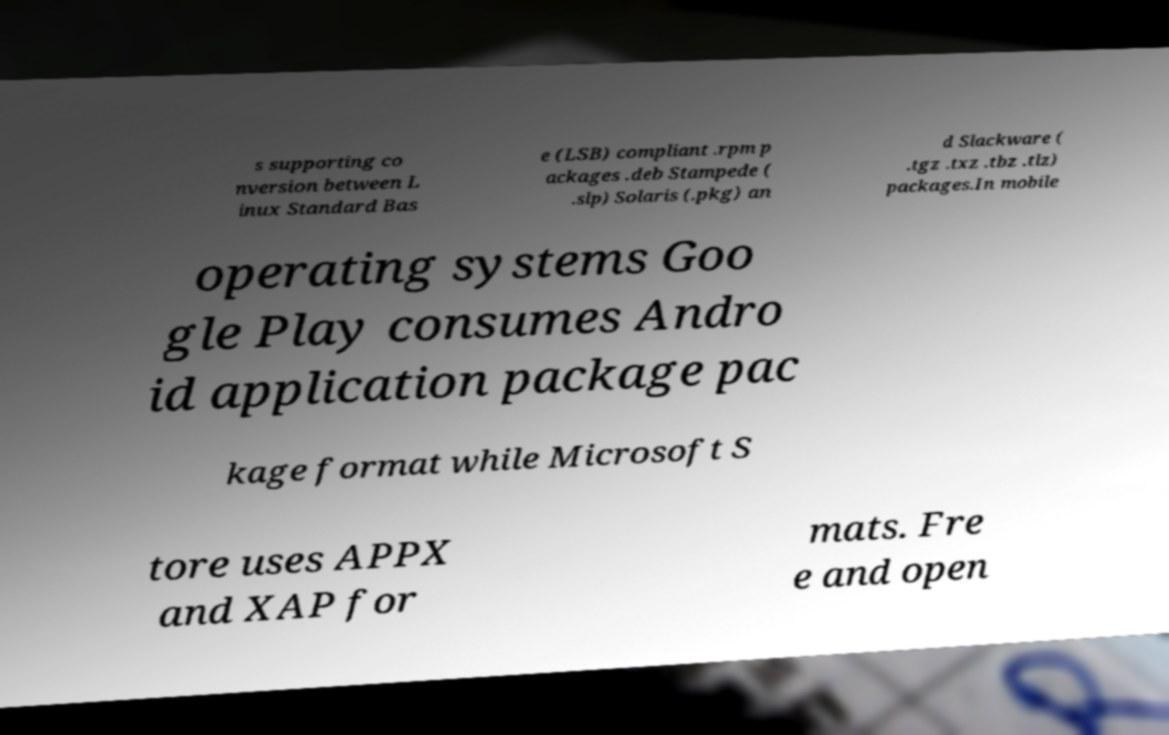Please read and relay the text visible in this image. What does it say? s supporting co nversion between L inux Standard Bas e (LSB) compliant .rpm p ackages .deb Stampede ( .slp) Solaris (.pkg) an d Slackware ( .tgz .txz .tbz .tlz) packages.In mobile operating systems Goo gle Play consumes Andro id application package pac kage format while Microsoft S tore uses APPX and XAP for mats. Fre e and open 